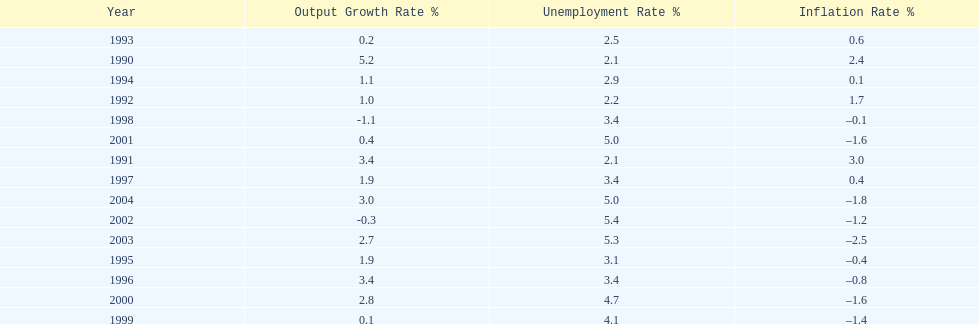When in the 1990's did the inflation rate first become negative? 1995. 